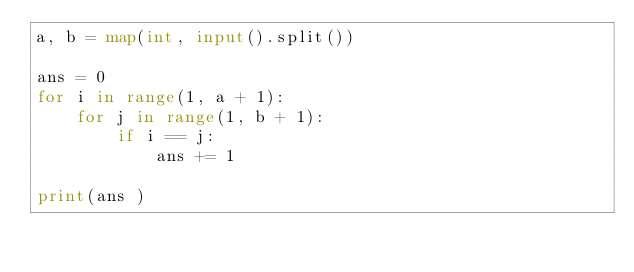<code> <loc_0><loc_0><loc_500><loc_500><_Python_>a, b = map(int, input().split())

ans = 0
for i in range(1, a + 1):
    for j in range(1, b + 1):
        if i == j:
            ans += 1

print(ans )</code> 